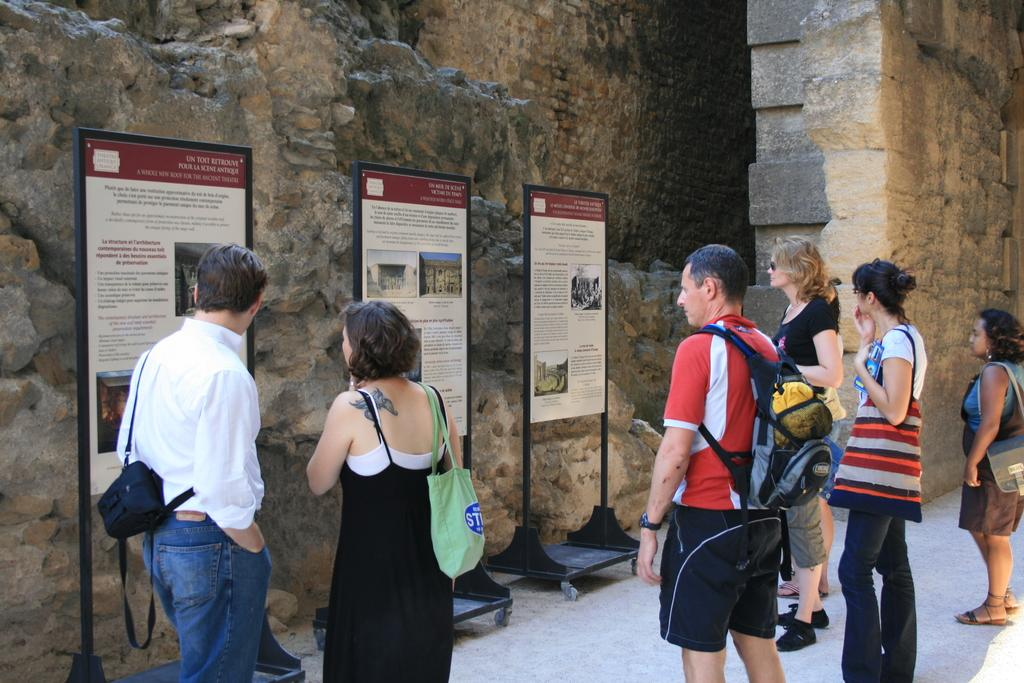What are the people in the image doing? The people in the image are standing and holding bags. What can be seen attached to the boards in the image? There are posters attached to the boards in the image. What type of structure is depicted in the background of the image? The image appears to depict an historical building. What type of tools is the carpenter using to work on the cattle in the image? There is no carpenter or cattle present in the image. How does the image turn into a different scene after a few seconds? The image does not change or turn into a different scene; it remains static. 